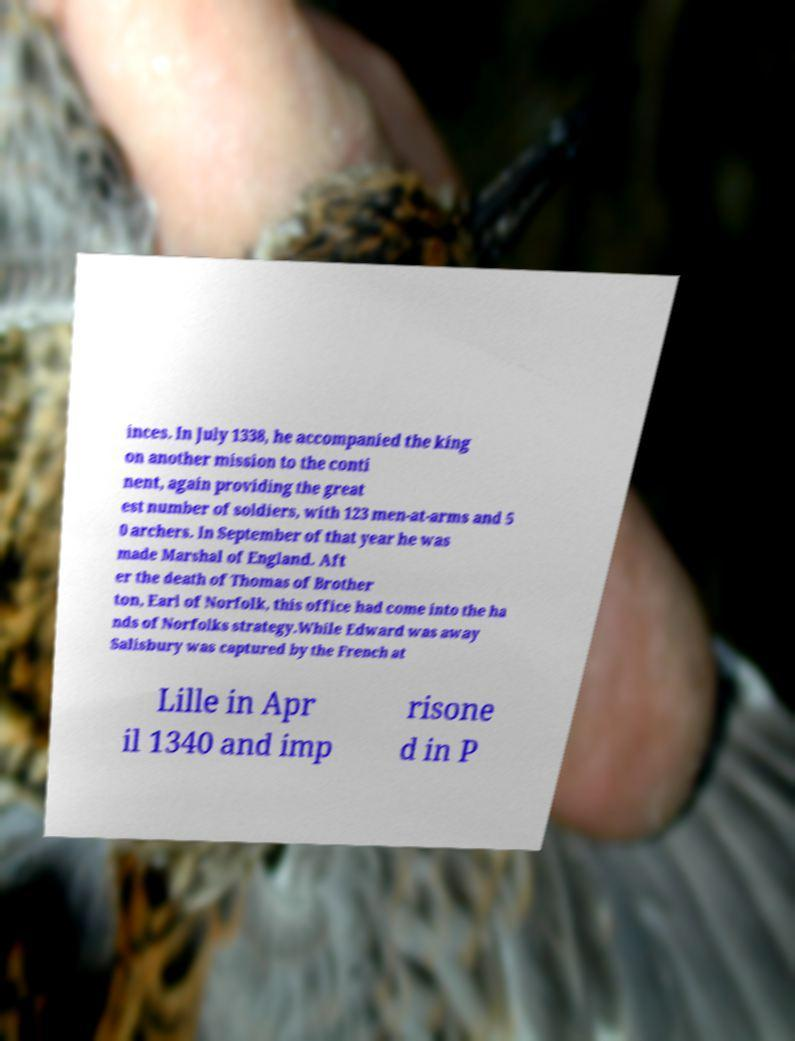Can you accurately transcribe the text from the provided image for me? inces. In July 1338, he accompanied the king on another mission to the conti nent, again providing the great est number of soldiers, with 123 men-at-arms and 5 0 archers. In September of that year he was made Marshal of England. Aft er the death of Thomas of Brother ton, Earl of Norfolk, this office had come into the ha nds of Norfolks strategy.While Edward was away Salisbury was captured by the French at Lille in Apr il 1340 and imp risone d in P 